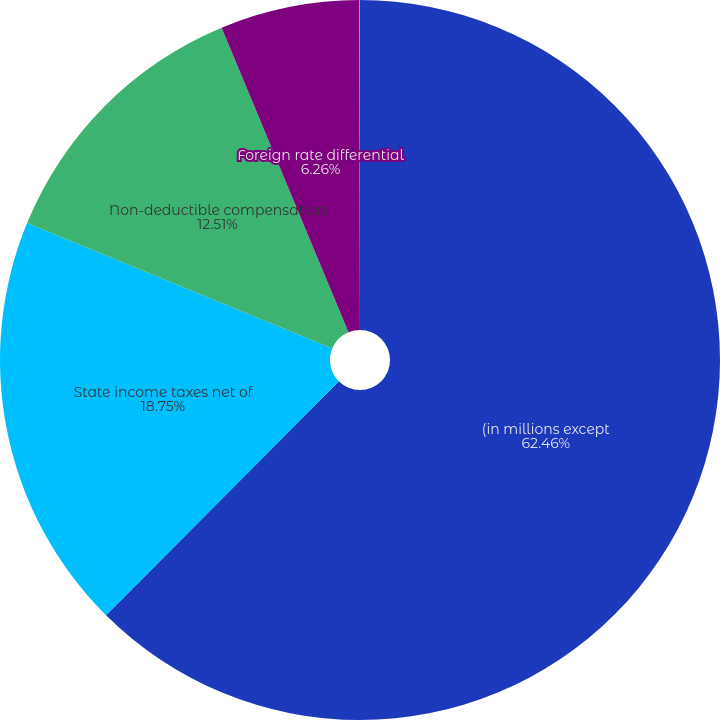Convert chart. <chart><loc_0><loc_0><loc_500><loc_500><pie_chart><fcel>(in millions except<fcel>State income taxes net of<fcel>Non-deductible compensation<fcel>Foreign rate differential<fcel>Other net<nl><fcel>62.46%<fcel>18.75%<fcel>12.51%<fcel>6.26%<fcel>0.02%<nl></chart> 